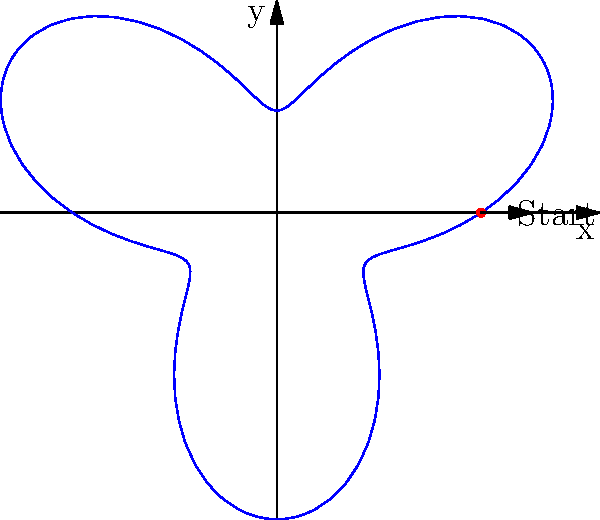As a mixed martial artist known for your powerful spinning back fist, you're analyzing the trajectory of this technique. The path of your fist can be modeled using the polar equation $r = 2 + \sin(3\theta)$, where $r$ is the distance from your body's center of rotation and $\theta$ is the angle of rotation. How many lobes (maximum extensions) does the trajectory have, and how might this information be useful for sponsorship opportunities? To determine the number of lobes in the trajectory, we need to analyze the polar equation $r = 2 + \sin(3\theta)$:

1. The sine function has a period of $2\pi$.
2. In this equation, the angle is multiplied by 3, so the period of the entire function is $\frac{2\pi}{3}$.
3. This means the pattern repeats three times over a full rotation ($2\pi$).
4. Each repetition corresponds to one lobe or maximum extension of the fist.

Therefore, the trajectory has 3 lobes.

This information can be useful for sponsorship opportunities in several ways:

1. Technical proficiency: It demonstrates your understanding of the mechanics behind your signature move, which can appeal to sponsors looking for knowledgeable athletes.
2. Marketing potential: The unique three-lobed pattern could be used in branding or logo design for sponsorship merchandise.
3. Performance analysis: This model shows your ability to break down complex movements, which could attract sponsors from sports technology or analytics sectors.
4. Training innovation: The mathematical model could be used to develop training programs or equipment, potentially leading to partnerships with fitness brands.

By showcasing this technical knowledge, you demonstrate value beyond just physical skills, making you a more attractive candidate for diverse sponsorship deals.
Answer: 3 lobes; demonstrates technical knowledge, marketing potential, and innovation opportunities for sponsors. 